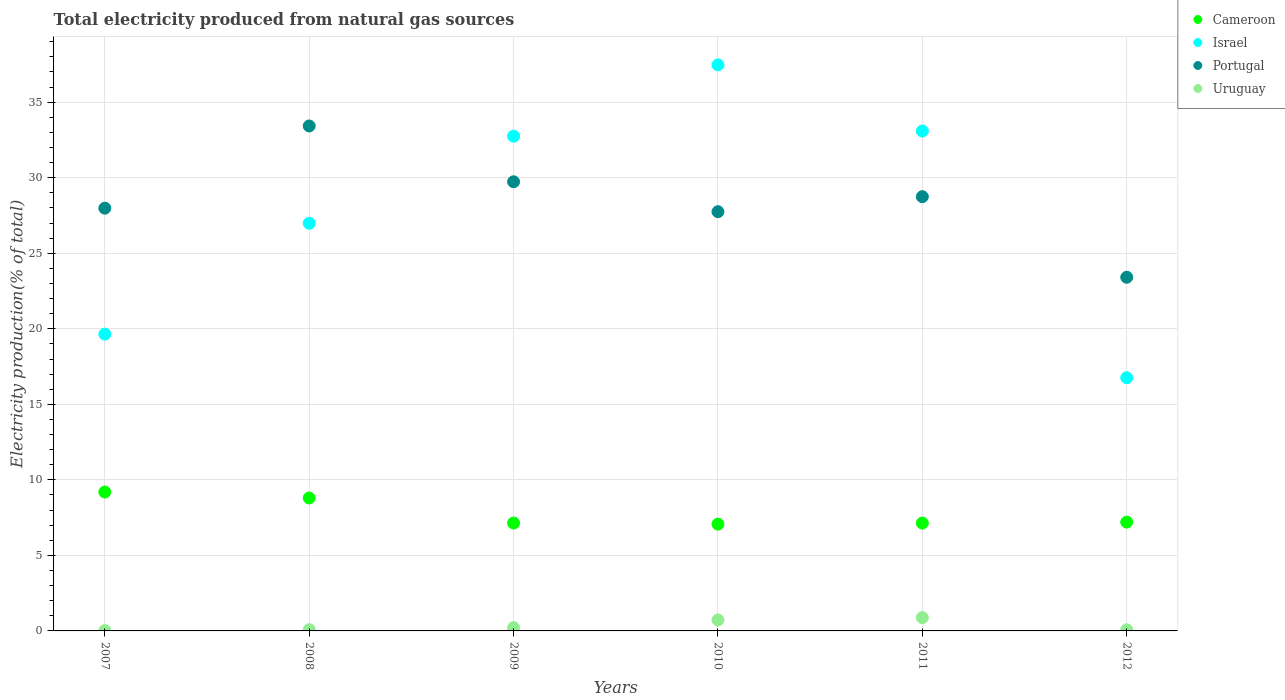How many different coloured dotlines are there?
Your answer should be compact. 4. Is the number of dotlines equal to the number of legend labels?
Offer a terse response. Yes. What is the total electricity produced in Cameroon in 2011?
Give a very brief answer. 7.14. Across all years, what is the maximum total electricity produced in Cameroon?
Your answer should be very brief. 9.19. Across all years, what is the minimum total electricity produced in Uruguay?
Your answer should be compact. 0.02. In which year was the total electricity produced in Cameroon maximum?
Keep it short and to the point. 2007. In which year was the total electricity produced in Cameroon minimum?
Offer a terse response. 2010. What is the total total electricity produced in Portugal in the graph?
Give a very brief answer. 171.05. What is the difference between the total electricity produced in Cameroon in 2007 and that in 2011?
Offer a terse response. 2.05. What is the difference between the total electricity produced in Uruguay in 2009 and the total electricity produced in Portugal in 2012?
Make the answer very short. -23.2. What is the average total electricity produced in Uruguay per year?
Ensure brevity in your answer.  0.33. In the year 2009, what is the difference between the total electricity produced in Uruguay and total electricity produced in Cameroon?
Ensure brevity in your answer.  -6.93. What is the ratio of the total electricity produced in Uruguay in 2007 to that in 2010?
Keep it short and to the point. 0.03. What is the difference between the highest and the second highest total electricity produced in Uruguay?
Your answer should be compact. 0.15. What is the difference between the highest and the lowest total electricity produced in Uruguay?
Your answer should be very brief. 0.86. In how many years, is the total electricity produced in Uruguay greater than the average total electricity produced in Uruguay taken over all years?
Keep it short and to the point. 2. Is the sum of the total electricity produced in Uruguay in 2008 and 2010 greater than the maximum total electricity produced in Portugal across all years?
Ensure brevity in your answer.  No. Is the total electricity produced in Portugal strictly greater than the total electricity produced in Israel over the years?
Provide a short and direct response. No. Is the total electricity produced in Portugal strictly less than the total electricity produced in Uruguay over the years?
Ensure brevity in your answer.  No. How many dotlines are there?
Ensure brevity in your answer.  4. How many years are there in the graph?
Ensure brevity in your answer.  6. Does the graph contain any zero values?
Provide a succinct answer. No. What is the title of the graph?
Offer a very short reply. Total electricity produced from natural gas sources. Does "Niger" appear as one of the legend labels in the graph?
Provide a short and direct response. No. What is the label or title of the Y-axis?
Your answer should be very brief. Electricity production(% of total). What is the Electricity production(% of total) of Cameroon in 2007?
Your answer should be very brief. 9.19. What is the Electricity production(% of total) of Israel in 2007?
Ensure brevity in your answer.  19.65. What is the Electricity production(% of total) in Portugal in 2007?
Your response must be concise. 27.99. What is the Electricity production(% of total) of Uruguay in 2007?
Offer a very short reply. 0.02. What is the Electricity production(% of total) in Cameroon in 2008?
Your answer should be compact. 8.8. What is the Electricity production(% of total) in Israel in 2008?
Provide a short and direct response. 26.99. What is the Electricity production(% of total) in Portugal in 2008?
Keep it short and to the point. 33.43. What is the Electricity production(% of total) of Uruguay in 2008?
Your response must be concise. 0.08. What is the Electricity production(% of total) in Cameroon in 2009?
Make the answer very short. 7.14. What is the Electricity production(% of total) of Israel in 2009?
Your response must be concise. 32.75. What is the Electricity production(% of total) of Portugal in 2009?
Offer a terse response. 29.73. What is the Electricity production(% of total) in Uruguay in 2009?
Your answer should be very brief. 0.21. What is the Electricity production(% of total) of Cameroon in 2010?
Ensure brevity in your answer.  7.07. What is the Electricity production(% of total) in Israel in 2010?
Make the answer very short. 37.47. What is the Electricity production(% of total) of Portugal in 2010?
Offer a very short reply. 27.75. What is the Electricity production(% of total) in Uruguay in 2010?
Ensure brevity in your answer.  0.73. What is the Electricity production(% of total) in Cameroon in 2011?
Keep it short and to the point. 7.14. What is the Electricity production(% of total) of Israel in 2011?
Give a very brief answer. 33.09. What is the Electricity production(% of total) of Portugal in 2011?
Make the answer very short. 28.75. What is the Electricity production(% of total) of Uruguay in 2011?
Provide a short and direct response. 0.88. What is the Electricity production(% of total) in Cameroon in 2012?
Give a very brief answer. 7.2. What is the Electricity production(% of total) of Israel in 2012?
Keep it short and to the point. 16.76. What is the Electricity production(% of total) of Portugal in 2012?
Make the answer very short. 23.41. What is the Electricity production(% of total) in Uruguay in 2012?
Your answer should be very brief. 0.08. Across all years, what is the maximum Electricity production(% of total) in Cameroon?
Make the answer very short. 9.19. Across all years, what is the maximum Electricity production(% of total) in Israel?
Offer a very short reply. 37.47. Across all years, what is the maximum Electricity production(% of total) of Portugal?
Ensure brevity in your answer.  33.43. Across all years, what is the maximum Electricity production(% of total) in Uruguay?
Make the answer very short. 0.88. Across all years, what is the minimum Electricity production(% of total) of Cameroon?
Your response must be concise. 7.07. Across all years, what is the minimum Electricity production(% of total) of Israel?
Offer a very short reply. 16.76. Across all years, what is the minimum Electricity production(% of total) of Portugal?
Ensure brevity in your answer.  23.41. Across all years, what is the minimum Electricity production(% of total) of Uruguay?
Your response must be concise. 0.02. What is the total Electricity production(% of total) in Cameroon in the graph?
Your answer should be compact. 46.55. What is the total Electricity production(% of total) of Israel in the graph?
Offer a terse response. 166.71. What is the total Electricity production(% of total) in Portugal in the graph?
Your answer should be compact. 171.05. What is the total Electricity production(% of total) of Uruguay in the graph?
Offer a very short reply. 2. What is the difference between the Electricity production(% of total) in Cameroon in 2007 and that in 2008?
Ensure brevity in your answer.  0.39. What is the difference between the Electricity production(% of total) in Israel in 2007 and that in 2008?
Provide a short and direct response. -7.34. What is the difference between the Electricity production(% of total) of Portugal in 2007 and that in 2008?
Keep it short and to the point. -5.44. What is the difference between the Electricity production(% of total) in Uruguay in 2007 and that in 2008?
Your response must be concise. -0.06. What is the difference between the Electricity production(% of total) of Cameroon in 2007 and that in 2009?
Your answer should be compact. 2.05. What is the difference between the Electricity production(% of total) in Israel in 2007 and that in 2009?
Provide a succinct answer. -13.1. What is the difference between the Electricity production(% of total) of Portugal in 2007 and that in 2009?
Offer a terse response. -1.75. What is the difference between the Electricity production(% of total) of Uruguay in 2007 and that in 2009?
Provide a short and direct response. -0.19. What is the difference between the Electricity production(% of total) of Cameroon in 2007 and that in 2010?
Offer a terse response. 2.12. What is the difference between the Electricity production(% of total) in Israel in 2007 and that in 2010?
Provide a short and direct response. -17.82. What is the difference between the Electricity production(% of total) in Portugal in 2007 and that in 2010?
Make the answer very short. 0.23. What is the difference between the Electricity production(% of total) of Uruguay in 2007 and that in 2010?
Your response must be concise. -0.71. What is the difference between the Electricity production(% of total) in Cameroon in 2007 and that in 2011?
Your response must be concise. 2.05. What is the difference between the Electricity production(% of total) of Israel in 2007 and that in 2011?
Give a very brief answer. -13.44. What is the difference between the Electricity production(% of total) of Portugal in 2007 and that in 2011?
Ensure brevity in your answer.  -0.76. What is the difference between the Electricity production(% of total) of Uruguay in 2007 and that in 2011?
Offer a terse response. -0.86. What is the difference between the Electricity production(% of total) of Cameroon in 2007 and that in 2012?
Ensure brevity in your answer.  1.99. What is the difference between the Electricity production(% of total) of Israel in 2007 and that in 2012?
Ensure brevity in your answer.  2.89. What is the difference between the Electricity production(% of total) in Portugal in 2007 and that in 2012?
Offer a very short reply. 4.57. What is the difference between the Electricity production(% of total) of Uruguay in 2007 and that in 2012?
Provide a short and direct response. -0.05. What is the difference between the Electricity production(% of total) in Cameroon in 2008 and that in 2009?
Offer a terse response. 1.66. What is the difference between the Electricity production(% of total) in Israel in 2008 and that in 2009?
Your answer should be very brief. -5.77. What is the difference between the Electricity production(% of total) of Portugal in 2008 and that in 2009?
Provide a succinct answer. 3.69. What is the difference between the Electricity production(% of total) in Uruguay in 2008 and that in 2009?
Provide a succinct answer. -0.13. What is the difference between the Electricity production(% of total) in Cameroon in 2008 and that in 2010?
Provide a succinct answer. 1.73. What is the difference between the Electricity production(% of total) in Israel in 2008 and that in 2010?
Provide a succinct answer. -10.49. What is the difference between the Electricity production(% of total) in Portugal in 2008 and that in 2010?
Your answer should be compact. 5.67. What is the difference between the Electricity production(% of total) in Uruguay in 2008 and that in 2010?
Keep it short and to the point. -0.65. What is the difference between the Electricity production(% of total) of Cameroon in 2008 and that in 2011?
Provide a short and direct response. 1.66. What is the difference between the Electricity production(% of total) of Israel in 2008 and that in 2011?
Provide a short and direct response. -6.11. What is the difference between the Electricity production(% of total) of Portugal in 2008 and that in 2011?
Provide a short and direct response. 4.68. What is the difference between the Electricity production(% of total) in Uruguay in 2008 and that in 2011?
Offer a terse response. -0.8. What is the difference between the Electricity production(% of total) in Cameroon in 2008 and that in 2012?
Keep it short and to the point. 1.6. What is the difference between the Electricity production(% of total) in Israel in 2008 and that in 2012?
Provide a succinct answer. 10.22. What is the difference between the Electricity production(% of total) of Portugal in 2008 and that in 2012?
Your answer should be compact. 10.01. What is the difference between the Electricity production(% of total) of Uruguay in 2008 and that in 2012?
Your response must be concise. 0. What is the difference between the Electricity production(% of total) in Cameroon in 2009 and that in 2010?
Offer a very short reply. 0.07. What is the difference between the Electricity production(% of total) in Israel in 2009 and that in 2010?
Give a very brief answer. -4.72. What is the difference between the Electricity production(% of total) in Portugal in 2009 and that in 2010?
Make the answer very short. 1.98. What is the difference between the Electricity production(% of total) in Uruguay in 2009 and that in 2010?
Ensure brevity in your answer.  -0.51. What is the difference between the Electricity production(% of total) of Cameroon in 2009 and that in 2011?
Keep it short and to the point. 0. What is the difference between the Electricity production(% of total) of Israel in 2009 and that in 2011?
Your response must be concise. -0.34. What is the difference between the Electricity production(% of total) of Portugal in 2009 and that in 2011?
Offer a terse response. 0.99. What is the difference between the Electricity production(% of total) in Uruguay in 2009 and that in 2011?
Your answer should be very brief. -0.67. What is the difference between the Electricity production(% of total) in Cameroon in 2009 and that in 2012?
Your answer should be very brief. -0.06. What is the difference between the Electricity production(% of total) of Israel in 2009 and that in 2012?
Keep it short and to the point. 15.99. What is the difference between the Electricity production(% of total) of Portugal in 2009 and that in 2012?
Ensure brevity in your answer.  6.32. What is the difference between the Electricity production(% of total) of Uruguay in 2009 and that in 2012?
Keep it short and to the point. 0.14. What is the difference between the Electricity production(% of total) in Cameroon in 2010 and that in 2011?
Your response must be concise. -0.07. What is the difference between the Electricity production(% of total) of Israel in 2010 and that in 2011?
Give a very brief answer. 4.38. What is the difference between the Electricity production(% of total) of Portugal in 2010 and that in 2011?
Keep it short and to the point. -1. What is the difference between the Electricity production(% of total) of Uruguay in 2010 and that in 2011?
Make the answer very short. -0.15. What is the difference between the Electricity production(% of total) in Cameroon in 2010 and that in 2012?
Offer a very short reply. -0.14. What is the difference between the Electricity production(% of total) of Israel in 2010 and that in 2012?
Keep it short and to the point. 20.71. What is the difference between the Electricity production(% of total) in Portugal in 2010 and that in 2012?
Make the answer very short. 4.34. What is the difference between the Electricity production(% of total) in Uruguay in 2010 and that in 2012?
Your answer should be compact. 0.65. What is the difference between the Electricity production(% of total) in Cameroon in 2011 and that in 2012?
Provide a short and direct response. -0.06. What is the difference between the Electricity production(% of total) of Israel in 2011 and that in 2012?
Your answer should be very brief. 16.33. What is the difference between the Electricity production(% of total) of Portugal in 2011 and that in 2012?
Offer a terse response. 5.34. What is the difference between the Electricity production(% of total) in Uruguay in 2011 and that in 2012?
Your answer should be very brief. 0.8. What is the difference between the Electricity production(% of total) in Cameroon in 2007 and the Electricity production(% of total) in Israel in 2008?
Give a very brief answer. -17.79. What is the difference between the Electricity production(% of total) in Cameroon in 2007 and the Electricity production(% of total) in Portugal in 2008?
Your response must be concise. -24.23. What is the difference between the Electricity production(% of total) in Cameroon in 2007 and the Electricity production(% of total) in Uruguay in 2008?
Your answer should be very brief. 9.11. What is the difference between the Electricity production(% of total) of Israel in 2007 and the Electricity production(% of total) of Portugal in 2008?
Your response must be concise. -13.78. What is the difference between the Electricity production(% of total) of Israel in 2007 and the Electricity production(% of total) of Uruguay in 2008?
Your response must be concise. 19.57. What is the difference between the Electricity production(% of total) in Portugal in 2007 and the Electricity production(% of total) in Uruguay in 2008?
Ensure brevity in your answer.  27.91. What is the difference between the Electricity production(% of total) of Cameroon in 2007 and the Electricity production(% of total) of Israel in 2009?
Provide a succinct answer. -23.56. What is the difference between the Electricity production(% of total) of Cameroon in 2007 and the Electricity production(% of total) of Portugal in 2009?
Provide a short and direct response. -20.54. What is the difference between the Electricity production(% of total) in Cameroon in 2007 and the Electricity production(% of total) in Uruguay in 2009?
Offer a very short reply. 8.98. What is the difference between the Electricity production(% of total) in Israel in 2007 and the Electricity production(% of total) in Portugal in 2009?
Ensure brevity in your answer.  -10.08. What is the difference between the Electricity production(% of total) of Israel in 2007 and the Electricity production(% of total) of Uruguay in 2009?
Offer a terse response. 19.43. What is the difference between the Electricity production(% of total) of Portugal in 2007 and the Electricity production(% of total) of Uruguay in 2009?
Give a very brief answer. 27.77. What is the difference between the Electricity production(% of total) in Cameroon in 2007 and the Electricity production(% of total) in Israel in 2010?
Provide a short and direct response. -28.28. What is the difference between the Electricity production(% of total) of Cameroon in 2007 and the Electricity production(% of total) of Portugal in 2010?
Give a very brief answer. -18.56. What is the difference between the Electricity production(% of total) in Cameroon in 2007 and the Electricity production(% of total) in Uruguay in 2010?
Provide a succinct answer. 8.47. What is the difference between the Electricity production(% of total) in Israel in 2007 and the Electricity production(% of total) in Portugal in 2010?
Your response must be concise. -8.1. What is the difference between the Electricity production(% of total) in Israel in 2007 and the Electricity production(% of total) in Uruguay in 2010?
Provide a short and direct response. 18.92. What is the difference between the Electricity production(% of total) of Portugal in 2007 and the Electricity production(% of total) of Uruguay in 2010?
Provide a short and direct response. 27.26. What is the difference between the Electricity production(% of total) in Cameroon in 2007 and the Electricity production(% of total) in Israel in 2011?
Provide a short and direct response. -23.9. What is the difference between the Electricity production(% of total) of Cameroon in 2007 and the Electricity production(% of total) of Portugal in 2011?
Your response must be concise. -19.55. What is the difference between the Electricity production(% of total) in Cameroon in 2007 and the Electricity production(% of total) in Uruguay in 2011?
Ensure brevity in your answer.  8.31. What is the difference between the Electricity production(% of total) in Israel in 2007 and the Electricity production(% of total) in Portugal in 2011?
Provide a succinct answer. -9.1. What is the difference between the Electricity production(% of total) of Israel in 2007 and the Electricity production(% of total) of Uruguay in 2011?
Give a very brief answer. 18.77. What is the difference between the Electricity production(% of total) of Portugal in 2007 and the Electricity production(% of total) of Uruguay in 2011?
Provide a short and direct response. 27.11. What is the difference between the Electricity production(% of total) of Cameroon in 2007 and the Electricity production(% of total) of Israel in 2012?
Provide a succinct answer. -7.57. What is the difference between the Electricity production(% of total) of Cameroon in 2007 and the Electricity production(% of total) of Portugal in 2012?
Provide a succinct answer. -14.22. What is the difference between the Electricity production(% of total) of Cameroon in 2007 and the Electricity production(% of total) of Uruguay in 2012?
Provide a short and direct response. 9.12. What is the difference between the Electricity production(% of total) of Israel in 2007 and the Electricity production(% of total) of Portugal in 2012?
Keep it short and to the point. -3.76. What is the difference between the Electricity production(% of total) of Israel in 2007 and the Electricity production(% of total) of Uruguay in 2012?
Offer a very short reply. 19.57. What is the difference between the Electricity production(% of total) in Portugal in 2007 and the Electricity production(% of total) in Uruguay in 2012?
Provide a succinct answer. 27.91. What is the difference between the Electricity production(% of total) in Cameroon in 2008 and the Electricity production(% of total) in Israel in 2009?
Your response must be concise. -23.95. What is the difference between the Electricity production(% of total) of Cameroon in 2008 and the Electricity production(% of total) of Portugal in 2009?
Make the answer very short. -20.93. What is the difference between the Electricity production(% of total) of Cameroon in 2008 and the Electricity production(% of total) of Uruguay in 2009?
Provide a succinct answer. 8.59. What is the difference between the Electricity production(% of total) in Israel in 2008 and the Electricity production(% of total) in Portugal in 2009?
Provide a succinct answer. -2.75. What is the difference between the Electricity production(% of total) in Israel in 2008 and the Electricity production(% of total) in Uruguay in 2009?
Offer a very short reply. 26.77. What is the difference between the Electricity production(% of total) in Portugal in 2008 and the Electricity production(% of total) in Uruguay in 2009?
Give a very brief answer. 33.21. What is the difference between the Electricity production(% of total) of Cameroon in 2008 and the Electricity production(% of total) of Israel in 2010?
Provide a short and direct response. -28.67. What is the difference between the Electricity production(% of total) in Cameroon in 2008 and the Electricity production(% of total) in Portugal in 2010?
Your answer should be very brief. -18.95. What is the difference between the Electricity production(% of total) in Cameroon in 2008 and the Electricity production(% of total) in Uruguay in 2010?
Give a very brief answer. 8.07. What is the difference between the Electricity production(% of total) in Israel in 2008 and the Electricity production(% of total) in Portugal in 2010?
Offer a very short reply. -0.77. What is the difference between the Electricity production(% of total) in Israel in 2008 and the Electricity production(% of total) in Uruguay in 2010?
Your answer should be compact. 26.26. What is the difference between the Electricity production(% of total) in Portugal in 2008 and the Electricity production(% of total) in Uruguay in 2010?
Offer a terse response. 32.7. What is the difference between the Electricity production(% of total) of Cameroon in 2008 and the Electricity production(% of total) of Israel in 2011?
Provide a succinct answer. -24.29. What is the difference between the Electricity production(% of total) in Cameroon in 2008 and the Electricity production(% of total) in Portugal in 2011?
Ensure brevity in your answer.  -19.95. What is the difference between the Electricity production(% of total) of Cameroon in 2008 and the Electricity production(% of total) of Uruguay in 2011?
Make the answer very short. 7.92. What is the difference between the Electricity production(% of total) in Israel in 2008 and the Electricity production(% of total) in Portugal in 2011?
Your response must be concise. -1.76. What is the difference between the Electricity production(% of total) in Israel in 2008 and the Electricity production(% of total) in Uruguay in 2011?
Provide a succinct answer. 26.11. What is the difference between the Electricity production(% of total) of Portugal in 2008 and the Electricity production(% of total) of Uruguay in 2011?
Give a very brief answer. 32.55. What is the difference between the Electricity production(% of total) in Cameroon in 2008 and the Electricity production(% of total) in Israel in 2012?
Your answer should be compact. -7.96. What is the difference between the Electricity production(% of total) in Cameroon in 2008 and the Electricity production(% of total) in Portugal in 2012?
Your answer should be compact. -14.61. What is the difference between the Electricity production(% of total) in Cameroon in 2008 and the Electricity production(% of total) in Uruguay in 2012?
Provide a short and direct response. 8.73. What is the difference between the Electricity production(% of total) of Israel in 2008 and the Electricity production(% of total) of Portugal in 2012?
Keep it short and to the point. 3.57. What is the difference between the Electricity production(% of total) in Israel in 2008 and the Electricity production(% of total) in Uruguay in 2012?
Ensure brevity in your answer.  26.91. What is the difference between the Electricity production(% of total) of Portugal in 2008 and the Electricity production(% of total) of Uruguay in 2012?
Provide a succinct answer. 33.35. What is the difference between the Electricity production(% of total) of Cameroon in 2009 and the Electricity production(% of total) of Israel in 2010?
Keep it short and to the point. -30.33. What is the difference between the Electricity production(% of total) in Cameroon in 2009 and the Electricity production(% of total) in Portugal in 2010?
Provide a succinct answer. -20.61. What is the difference between the Electricity production(% of total) in Cameroon in 2009 and the Electricity production(% of total) in Uruguay in 2010?
Your answer should be very brief. 6.41. What is the difference between the Electricity production(% of total) in Israel in 2009 and the Electricity production(% of total) in Portugal in 2010?
Provide a short and direct response. 5. What is the difference between the Electricity production(% of total) in Israel in 2009 and the Electricity production(% of total) in Uruguay in 2010?
Your response must be concise. 32.02. What is the difference between the Electricity production(% of total) in Portugal in 2009 and the Electricity production(% of total) in Uruguay in 2010?
Your answer should be compact. 29. What is the difference between the Electricity production(% of total) of Cameroon in 2009 and the Electricity production(% of total) of Israel in 2011?
Your answer should be compact. -25.95. What is the difference between the Electricity production(% of total) of Cameroon in 2009 and the Electricity production(% of total) of Portugal in 2011?
Make the answer very short. -21.6. What is the difference between the Electricity production(% of total) in Cameroon in 2009 and the Electricity production(% of total) in Uruguay in 2011?
Make the answer very short. 6.26. What is the difference between the Electricity production(% of total) in Israel in 2009 and the Electricity production(% of total) in Portugal in 2011?
Your answer should be compact. 4.01. What is the difference between the Electricity production(% of total) of Israel in 2009 and the Electricity production(% of total) of Uruguay in 2011?
Make the answer very short. 31.87. What is the difference between the Electricity production(% of total) of Portugal in 2009 and the Electricity production(% of total) of Uruguay in 2011?
Give a very brief answer. 28.85. What is the difference between the Electricity production(% of total) of Cameroon in 2009 and the Electricity production(% of total) of Israel in 2012?
Offer a very short reply. -9.62. What is the difference between the Electricity production(% of total) of Cameroon in 2009 and the Electricity production(% of total) of Portugal in 2012?
Offer a very short reply. -16.27. What is the difference between the Electricity production(% of total) in Cameroon in 2009 and the Electricity production(% of total) in Uruguay in 2012?
Your response must be concise. 7.07. What is the difference between the Electricity production(% of total) in Israel in 2009 and the Electricity production(% of total) in Portugal in 2012?
Offer a very short reply. 9.34. What is the difference between the Electricity production(% of total) of Israel in 2009 and the Electricity production(% of total) of Uruguay in 2012?
Offer a terse response. 32.68. What is the difference between the Electricity production(% of total) in Portugal in 2009 and the Electricity production(% of total) in Uruguay in 2012?
Your answer should be compact. 29.66. What is the difference between the Electricity production(% of total) in Cameroon in 2010 and the Electricity production(% of total) in Israel in 2011?
Your answer should be very brief. -26.02. What is the difference between the Electricity production(% of total) in Cameroon in 2010 and the Electricity production(% of total) in Portugal in 2011?
Provide a succinct answer. -21.68. What is the difference between the Electricity production(% of total) of Cameroon in 2010 and the Electricity production(% of total) of Uruguay in 2011?
Provide a short and direct response. 6.19. What is the difference between the Electricity production(% of total) in Israel in 2010 and the Electricity production(% of total) in Portugal in 2011?
Offer a terse response. 8.73. What is the difference between the Electricity production(% of total) of Israel in 2010 and the Electricity production(% of total) of Uruguay in 2011?
Keep it short and to the point. 36.59. What is the difference between the Electricity production(% of total) in Portugal in 2010 and the Electricity production(% of total) in Uruguay in 2011?
Give a very brief answer. 26.87. What is the difference between the Electricity production(% of total) of Cameroon in 2010 and the Electricity production(% of total) of Israel in 2012?
Your response must be concise. -9.69. What is the difference between the Electricity production(% of total) of Cameroon in 2010 and the Electricity production(% of total) of Portugal in 2012?
Offer a very short reply. -16.34. What is the difference between the Electricity production(% of total) in Cameroon in 2010 and the Electricity production(% of total) in Uruguay in 2012?
Your answer should be compact. 6.99. What is the difference between the Electricity production(% of total) in Israel in 2010 and the Electricity production(% of total) in Portugal in 2012?
Provide a succinct answer. 14.06. What is the difference between the Electricity production(% of total) in Israel in 2010 and the Electricity production(% of total) in Uruguay in 2012?
Keep it short and to the point. 37.4. What is the difference between the Electricity production(% of total) in Portugal in 2010 and the Electricity production(% of total) in Uruguay in 2012?
Your response must be concise. 27.68. What is the difference between the Electricity production(% of total) of Cameroon in 2011 and the Electricity production(% of total) of Israel in 2012?
Your answer should be compact. -9.62. What is the difference between the Electricity production(% of total) in Cameroon in 2011 and the Electricity production(% of total) in Portugal in 2012?
Your answer should be very brief. -16.27. What is the difference between the Electricity production(% of total) of Cameroon in 2011 and the Electricity production(% of total) of Uruguay in 2012?
Ensure brevity in your answer.  7.06. What is the difference between the Electricity production(% of total) of Israel in 2011 and the Electricity production(% of total) of Portugal in 2012?
Your response must be concise. 9.68. What is the difference between the Electricity production(% of total) of Israel in 2011 and the Electricity production(% of total) of Uruguay in 2012?
Provide a succinct answer. 33.01. What is the difference between the Electricity production(% of total) of Portugal in 2011 and the Electricity production(% of total) of Uruguay in 2012?
Keep it short and to the point. 28.67. What is the average Electricity production(% of total) of Cameroon per year?
Give a very brief answer. 7.76. What is the average Electricity production(% of total) of Israel per year?
Offer a terse response. 27.78. What is the average Electricity production(% of total) in Portugal per year?
Provide a short and direct response. 28.51. What is the average Electricity production(% of total) in Uruguay per year?
Your answer should be compact. 0.33. In the year 2007, what is the difference between the Electricity production(% of total) in Cameroon and Electricity production(% of total) in Israel?
Give a very brief answer. -10.45. In the year 2007, what is the difference between the Electricity production(% of total) of Cameroon and Electricity production(% of total) of Portugal?
Give a very brief answer. -18.79. In the year 2007, what is the difference between the Electricity production(% of total) of Cameroon and Electricity production(% of total) of Uruguay?
Your response must be concise. 9.17. In the year 2007, what is the difference between the Electricity production(% of total) of Israel and Electricity production(% of total) of Portugal?
Keep it short and to the point. -8.34. In the year 2007, what is the difference between the Electricity production(% of total) in Israel and Electricity production(% of total) in Uruguay?
Your answer should be compact. 19.63. In the year 2007, what is the difference between the Electricity production(% of total) of Portugal and Electricity production(% of total) of Uruguay?
Make the answer very short. 27.96. In the year 2008, what is the difference between the Electricity production(% of total) in Cameroon and Electricity production(% of total) in Israel?
Your answer should be compact. -18.18. In the year 2008, what is the difference between the Electricity production(% of total) in Cameroon and Electricity production(% of total) in Portugal?
Offer a terse response. -24.62. In the year 2008, what is the difference between the Electricity production(% of total) of Cameroon and Electricity production(% of total) of Uruguay?
Make the answer very short. 8.72. In the year 2008, what is the difference between the Electricity production(% of total) in Israel and Electricity production(% of total) in Portugal?
Give a very brief answer. -6.44. In the year 2008, what is the difference between the Electricity production(% of total) of Israel and Electricity production(% of total) of Uruguay?
Give a very brief answer. 26.91. In the year 2008, what is the difference between the Electricity production(% of total) of Portugal and Electricity production(% of total) of Uruguay?
Your response must be concise. 33.35. In the year 2009, what is the difference between the Electricity production(% of total) in Cameroon and Electricity production(% of total) in Israel?
Your answer should be compact. -25.61. In the year 2009, what is the difference between the Electricity production(% of total) of Cameroon and Electricity production(% of total) of Portugal?
Make the answer very short. -22.59. In the year 2009, what is the difference between the Electricity production(% of total) in Cameroon and Electricity production(% of total) in Uruguay?
Give a very brief answer. 6.93. In the year 2009, what is the difference between the Electricity production(% of total) of Israel and Electricity production(% of total) of Portugal?
Offer a very short reply. 3.02. In the year 2009, what is the difference between the Electricity production(% of total) in Israel and Electricity production(% of total) in Uruguay?
Offer a very short reply. 32.54. In the year 2009, what is the difference between the Electricity production(% of total) in Portugal and Electricity production(% of total) in Uruguay?
Offer a terse response. 29.52. In the year 2010, what is the difference between the Electricity production(% of total) of Cameroon and Electricity production(% of total) of Israel?
Keep it short and to the point. -30.4. In the year 2010, what is the difference between the Electricity production(% of total) in Cameroon and Electricity production(% of total) in Portugal?
Ensure brevity in your answer.  -20.68. In the year 2010, what is the difference between the Electricity production(% of total) in Cameroon and Electricity production(% of total) in Uruguay?
Your answer should be compact. 6.34. In the year 2010, what is the difference between the Electricity production(% of total) in Israel and Electricity production(% of total) in Portugal?
Ensure brevity in your answer.  9.72. In the year 2010, what is the difference between the Electricity production(% of total) of Israel and Electricity production(% of total) of Uruguay?
Your answer should be very brief. 36.74. In the year 2010, what is the difference between the Electricity production(% of total) in Portugal and Electricity production(% of total) in Uruguay?
Keep it short and to the point. 27.02. In the year 2011, what is the difference between the Electricity production(% of total) of Cameroon and Electricity production(% of total) of Israel?
Your answer should be compact. -25.95. In the year 2011, what is the difference between the Electricity production(% of total) in Cameroon and Electricity production(% of total) in Portugal?
Provide a succinct answer. -21.61. In the year 2011, what is the difference between the Electricity production(% of total) in Cameroon and Electricity production(% of total) in Uruguay?
Your response must be concise. 6.26. In the year 2011, what is the difference between the Electricity production(% of total) of Israel and Electricity production(% of total) of Portugal?
Keep it short and to the point. 4.34. In the year 2011, what is the difference between the Electricity production(% of total) in Israel and Electricity production(% of total) in Uruguay?
Make the answer very short. 32.21. In the year 2011, what is the difference between the Electricity production(% of total) of Portugal and Electricity production(% of total) of Uruguay?
Your answer should be compact. 27.87. In the year 2012, what is the difference between the Electricity production(% of total) in Cameroon and Electricity production(% of total) in Israel?
Keep it short and to the point. -9.56. In the year 2012, what is the difference between the Electricity production(% of total) of Cameroon and Electricity production(% of total) of Portugal?
Keep it short and to the point. -16.21. In the year 2012, what is the difference between the Electricity production(% of total) in Cameroon and Electricity production(% of total) in Uruguay?
Offer a very short reply. 7.13. In the year 2012, what is the difference between the Electricity production(% of total) in Israel and Electricity production(% of total) in Portugal?
Your answer should be compact. -6.65. In the year 2012, what is the difference between the Electricity production(% of total) of Israel and Electricity production(% of total) of Uruguay?
Your answer should be very brief. 16.69. In the year 2012, what is the difference between the Electricity production(% of total) of Portugal and Electricity production(% of total) of Uruguay?
Provide a succinct answer. 23.34. What is the ratio of the Electricity production(% of total) of Cameroon in 2007 to that in 2008?
Make the answer very short. 1.04. What is the ratio of the Electricity production(% of total) of Israel in 2007 to that in 2008?
Keep it short and to the point. 0.73. What is the ratio of the Electricity production(% of total) of Portugal in 2007 to that in 2008?
Your answer should be very brief. 0.84. What is the ratio of the Electricity production(% of total) in Uruguay in 2007 to that in 2008?
Offer a terse response. 0.27. What is the ratio of the Electricity production(% of total) of Cameroon in 2007 to that in 2009?
Your response must be concise. 1.29. What is the ratio of the Electricity production(% of total) in Israel in 2007 to that in 2009?
Offer a very short reply. 0.6. What is the ratio of the Electricity production(% of total) in Portugal in 2007 to that in 2009?
Provide a short and direct response. 0.94. What is the ratio of the Electricity production(% of total) in Uruguay in 2007 to that in 2009?
Your answer should be compact. 0.1. What is the ratio of the Electricity production(% of total) of Cameroon in 2007 to that in 2010?
Offer a terse response. 1.3. What is the ratio of the Electricity production(% of total) of Israel in 2007 to that in 2010?
Your answer should be compact. 0.52. What is the ratio of the Electricity production(% of total) of Portugal in 2007 to that in 2010?
Your answer should be compact. 1.01. What is the ratio of the Electricity production(% of total) of Uruguay in 2007 to that in 2010?
Make the answer very short. 0.03. What is the ratio of the Electricity production(% of total) of Cameroon in 2007 to that in 2011?
Provide a short and direct response. 1.29. What is the ratio of the Electricity production(% of total) in Israel in 2007 to that in 2011?
Provide a succinct answer. 0.59. What is the ratio of the Electricity production(% of total) of Portugal in 2007 to that in 2011?
Provide a succinct answer. 0.97. What is the ratio of the Electricity production(% of total) of Uruguay in 2007 to that in 2011?
Your response must be concise. 0.02. What is the ratio of the Electricity production(% of total) of Cameroon in 2007 to that in 2012?
Provide a short and direct response. 1.28. What is the ratio of the Electricity production(% of total) in Israel in 2007 to that in 2012?
Ensure brevity in your answer.  1.17. What is the ratio of the Electricity production(% of total) of Portugal in 2007 to that in 2012?
Offer a terse response. 1.2. What is the ratio of the Electricity production(% of total) of Uruguay in 2007 to that in 2012?
Offer a very short reply. 0.28. What is the ratio of the Electricity production(% of total) in Cameroon in 2008 to that in 2009?
Your answer should be very brief. 1.23. What is the ratio of the Electricity production(% of total) in Israel in 2008 to that in 2009?
Ensure brevity in your answer.  0.82. What is the ratio of the Electricity production(% of total) of Portugal in 2008 to that in 2009?
Your answer should be very brief. 1.12. What is the ratio of the Electricity production(% of total) of Uruguay in 2008 to that in 2009?
Give a very brief answer. 0.37. What is the ratio of the Electricity production(% of total) of Cameroon in 2008 to that in 2010?
Your response must be concise. 1.25. What is the ratio of the Electricity production(% of total) in Israel in 2008 to that in 2010?
Offer a terse response. 0.72. What is the ratio of the Electricity production(% of total) in Portugal in 2008 to that in 2010?
Offer a terse response. 1.2. What is the ratio of the Electricity production(% of total) in Uruguay in 2008 to that in 2010?
Your answer should be compact. 0.11. What is the ratio of the Electricity production(% of total) of Cameroon in 2008 to that in 2011?
Your answer should be compact. 1.23. What is the ratio of the Electricity production(% of total) in Israel in 2008 to that in 2011?
Your answer should be compact. 0.82. What is the ratio of the Electricity production(% of total) in Portugal in 2008 to that in 2011?
Your response must be concise. 1.16. What is the ratio of the Electricity production(% of total) in Uruguay in 2008 to that in 2011?
Make the answer very short. 0.09. What is the ratio of the Electricity production(% of total) of Cameroon in 2008 to that in 2012?
Make the answer very short. 1.22. What is the ratio of the Electricity production(% of total) in Israel in 2008 to that in 2012?
Offer a terse response. 1.61. What is the ratio of the Electricity production(% of total) in Portugal in 2008 to that in 2012?
Provide a succinct answer. 1.43. What is the ratio of the Electricity production(% of total) in Uruguay in 2008 to that in 2012?
Your answer should be compact. 1.06. What is the ratio of the Electricity production(% of total) in Cameroon in 2009 to that in 2010?
Give a very brief answer. 1.01. What is the ratio of the Electricity production(% of total) of Israel in 2009 to that in 2010?
Give a very brief answer. 0.87. What is the ratio of the Electricity production(% of total) in Portugal in 2009 to that in 2010?
Keep it short and to the point. 1.07. What is the ratio of the Electricity production(% of total) of Uruguay in 2009 to that in 2010?
Offer a terse response. 0.29. What is the ratio of the Electricity production(% of total) of Cameroon in 2009 to that in 2011?
Your response must be concise. 1. What is the ratio of the Electricity production(% of total) of Portugal in 2009 to that in 2011?
Keep it short and to the point. 1.03. What is the ratio of the Electricity production(% of total) in Uruguay in 2009 to that in 2011?
Make the answer very short. 0.24. What is the ratio of the Electricity production(% of total) of Israel in 2009 to that in 2012?
Give a very brief answer. 1.95. What is the ratio of the Electricity production(% of total) of Portugal in 2009 to that in 2012?
Offer a terse response. 1.27. What is the ratio of the Electricity production(% of total) of Uruguay in 2009 to that in 2012?
Your answer should be compact. 2.84. What is the ratio of the Electricity production(% of total) of Israel in 2010 to that in 2011?
Make the answer very short. 1.13. What is the ratio of the Electricity production(% of total) in Portugal in 2010 to that in 2011?
Your answer should be compact. 0.97. What is the ratio of the Electricity production(% of total) in Uruguay in 2010 to that in 2011?
Provide a succinct answer. 0.83. What is the ratio of the Electricity production(% of total) in Cameroon in 2010 to that in 2012?
Give a very brief answer. 0.98. What is the ratio of the Electricity production(% of total) in Israel in 2010 to that in 2012?
Your answer should be very brief. 2.24. What is the ratio of the Electricity production(% of total) of Portugal in 2010 to that in 2012?
Offer a terse response. 1.19. What is the ratio of the Electricity production(% of total) in Uruguay in 2010 to that in 2012?
Offer a terse response. 9.64. What is the ratio of the Electricity production(% of total) in Israel in 2011 to that in 2012?
Offer a terse response. 1.97. What is the ratio of the Electricity production(% of total) in Portugal in 2011 to that in 2012?
Your answer should be compact. 1.23. What is the ratio of the Electricity production(% of total) of Uruguay in 2011 to that in 2012?
Offer a very short reply. 11.66. What is the difference between the highest and the second highest Electricity production(% of total) in Cameroon?
Offer a very short reply. 0.39. What is the difference between the highest and the second highest Electricity production(% of total) of Israel?
Make the answer very short. 4.38. What is the difference between the highest and the second highest Electricity production(% of total) in Portugal?
Give a very brief answer. 3.69. What is the difference between the highest and the second highest Electricity production(% of total) of Uruguay?
Make the answer very short. 0.15. What is the difference between the highest and the lowest Electricity production(% of total) in Cameroon?
Your response must be concise. 2.12. What is the difference between the highest and the lowest Electricity production(% of total) in Israel?
Offer a terse response. 20.71. What is the difference between the highest and the lowest Electricity production(% of total) of Portugal?
Provide a succinct answer. 10.01. What is the difference between the highest and the lowest Electricity production(% of total) of Uruguay?
Your answer should be very brief. 0.86. 